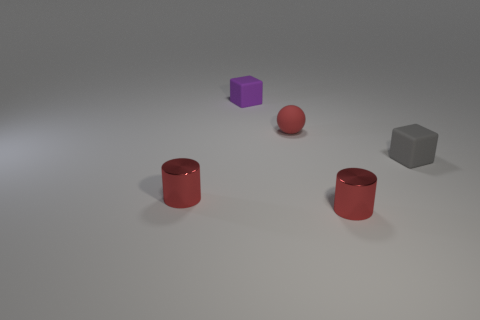Add 5 matte balls. How many objects exist? 10 Subtract 0 green blocks. How many objects are left? 5 Subtract all spheres. How many objects are left? 4 Subtract 1 cylinders. How many cylinders are left? 1 Subtract all gray cubes. Subtract all cyan cylinders. How many cubes are left? 1 Subtract all red cubes. How many purple spheres are left? 0 Subtract all small rubber things. Subtract all gray spheres. How many objects are left? 2 Add 5 spheres. How many spheres are left? 6 Add 4 tiny gray rubber objects. How many tiny gray rubber objects exist? 5 